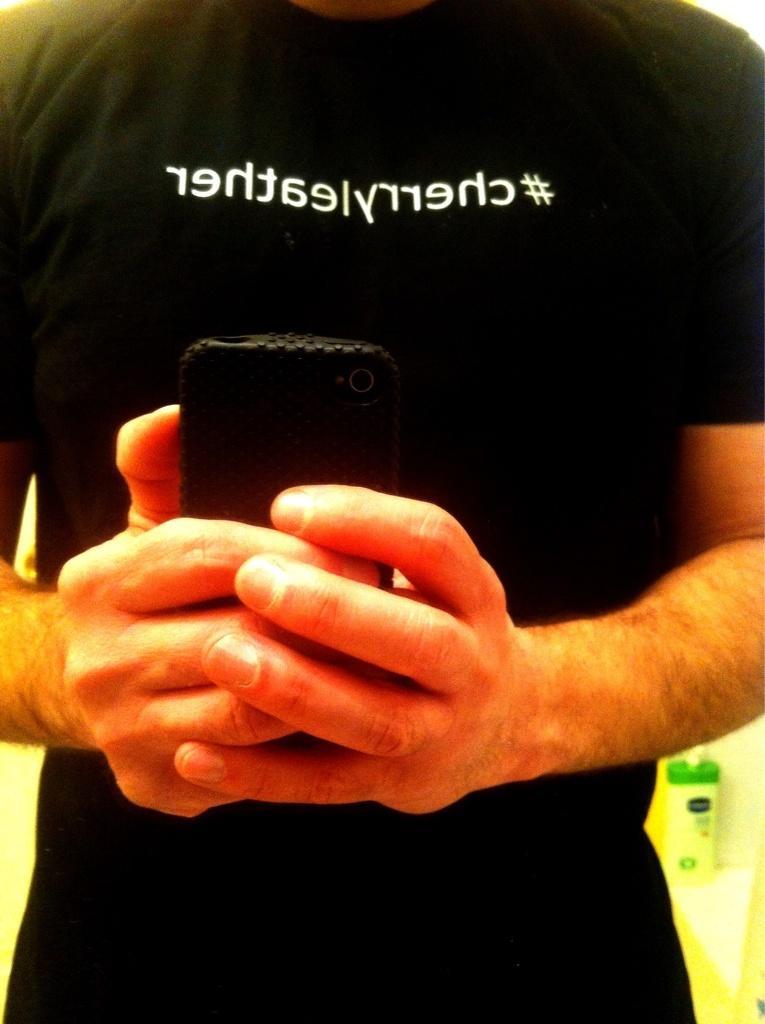Describe this image in one or two sentences. A person wore black t-shirt and holding a mobile with his hands. Something written on this black t-shirt. Far there is a bottle. 